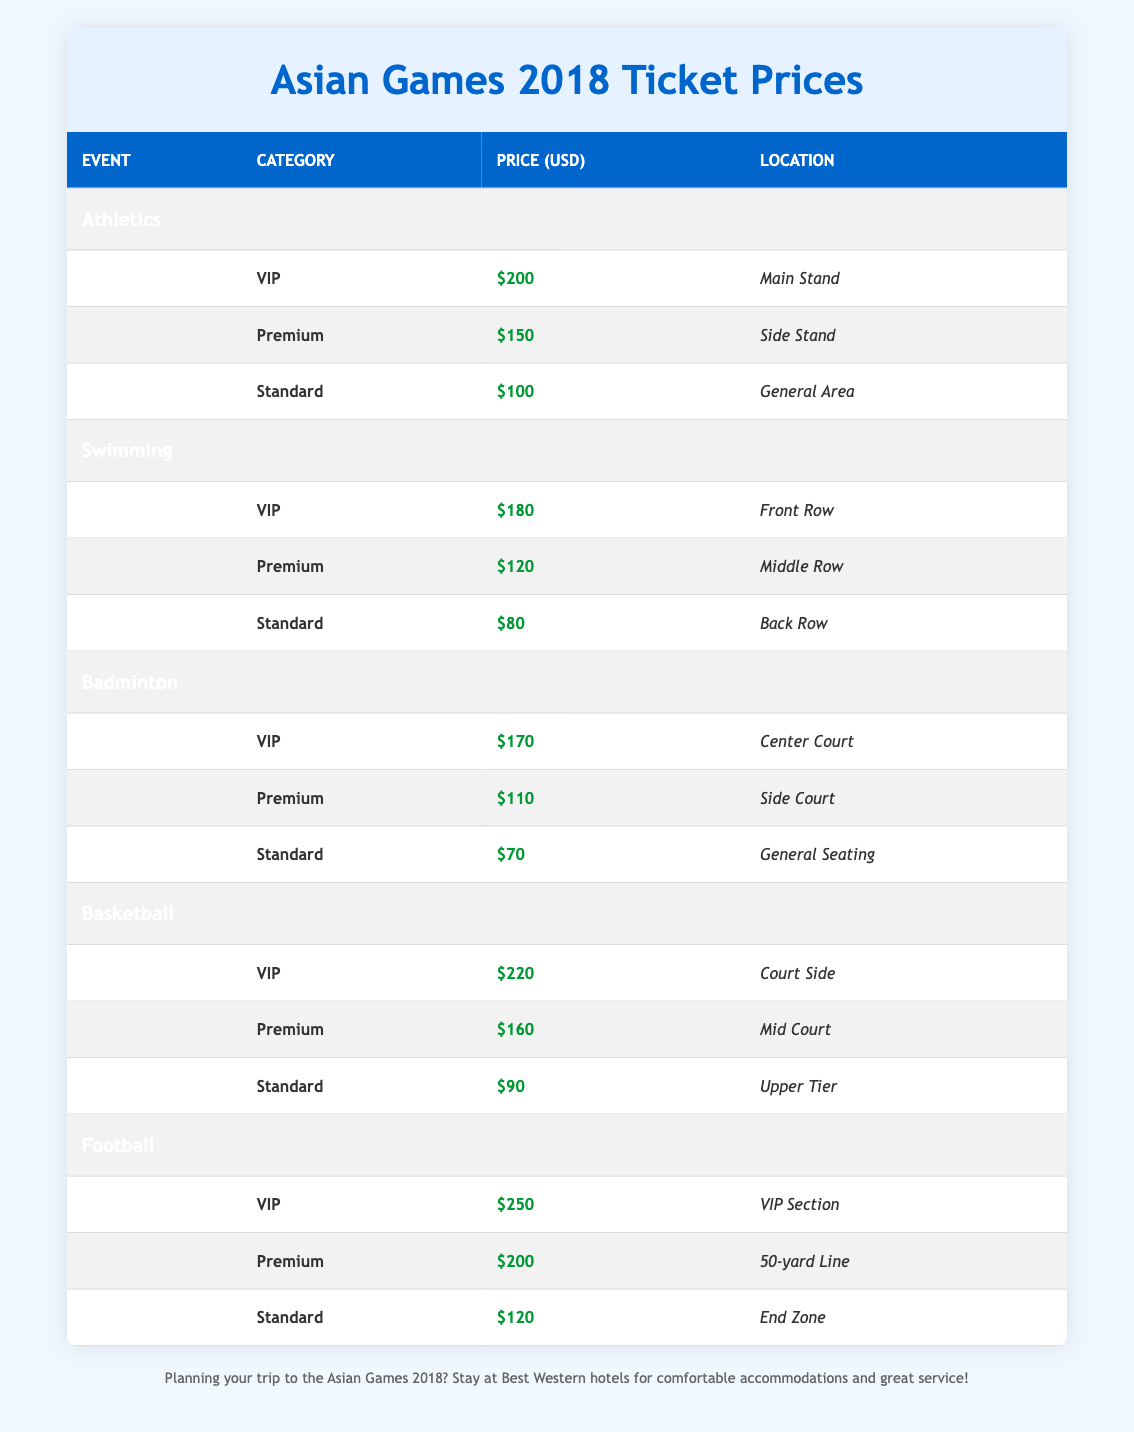What is the ticket price for VIP seating in Athletics? The table specifies the ticket prices for different seating categories in Athletics. For VIP seating, the ticket price is listed as $200.
Answer: 200 Which event has the highest ticket price for Premium seating? By looking at the Premium seating prices across all events, Basketball has the highest price at $160, while Football costs $200 and Swimming costs $120. Therefore, Basketball is the correct answer.
Answer: Basketball What is the average ticket price for Standard seating across all events? The Standard prices are: Athletics - $100, Swimming - $80, Badminton - $70, Basketball - $90, and Football - $120. The sum of these prices is $100 + $80 + $70 + $90 + $120 = $460. To find the average, we divide by the number of events (5), yielding $460 / 5 = $92.
Answer: 92 Is the price for Standard seating in Swimming higher than in Badminton? The Standard seating price for Swimming is $80, while for Badminton, it is $70. Since $80 is greater than $70, the statement is true.
Answer: Yes What is the total cost for a VIP ticket for Basketball and Standard ticket for Football? For Basketball, the VIP ticket costs $220, and for Football, the Standard ticket costs $120. Adding these two prices together, $220 + $120 gives us a total of $340 for both tickets.
Answer: 340 Which seating category in Football is less expensive than the Premium seating in Badminton? The Premium seating in Badminton costs $110, while in Football, the Standard seating costs $120 which is higher than $110. However, only the Standard seating in Badminton at $70 is less expensive than the Premium seating of $110. Therefore, the answer is Standard in Badminton.
Answer: Standard Which event has the lowest ticket price for any category? By checking the table, the lowest ticket price listed is $70 for Standard seating in Badminton. This price is lower than the prices for any other event's categories.
Answer: Badminton What is the difference between the ticket prices for VIP seating in Football and Basketball? The VIP seating price for Football is $250, and for Basketball, it is $220. The difference is calculated by $250 - $220, which equals $30.
Answer: 30 